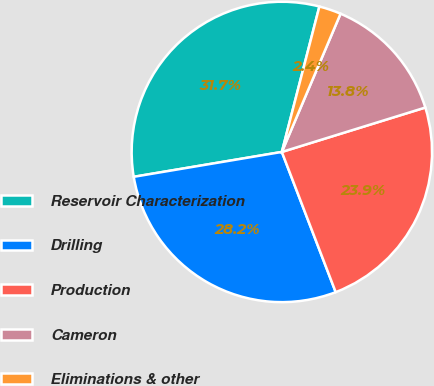<chart> <loc_0><loc_0><loc_500><loc_500><pie_chart><fcel>Reservoir Characterization<fcel>Drilling<fcel>Production<fcel>Cameron<fcel>Eliminations & other<nl><fcel>31.67%<fcel>28.19%<fcel>23.94%<fcel>13.83%<fcel>2.37%<nl></chart> 